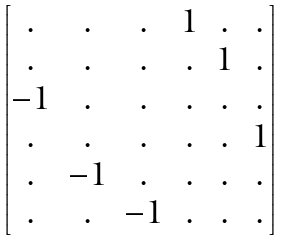Convert formula to latex. <formula><loc_0><loc_0><loc_500><loc_500>\begin{bmatrix} . & . & . & 1 & . & . \\ . & . & . & . & 1 & . \\ - 1 & . & . & . & . & . \\ . & . & . & . & . & 1 \\ . & - 1 & . & . & . & . \\ . & . & - 1 & . & . & . \end{bmatrix}</formula> 